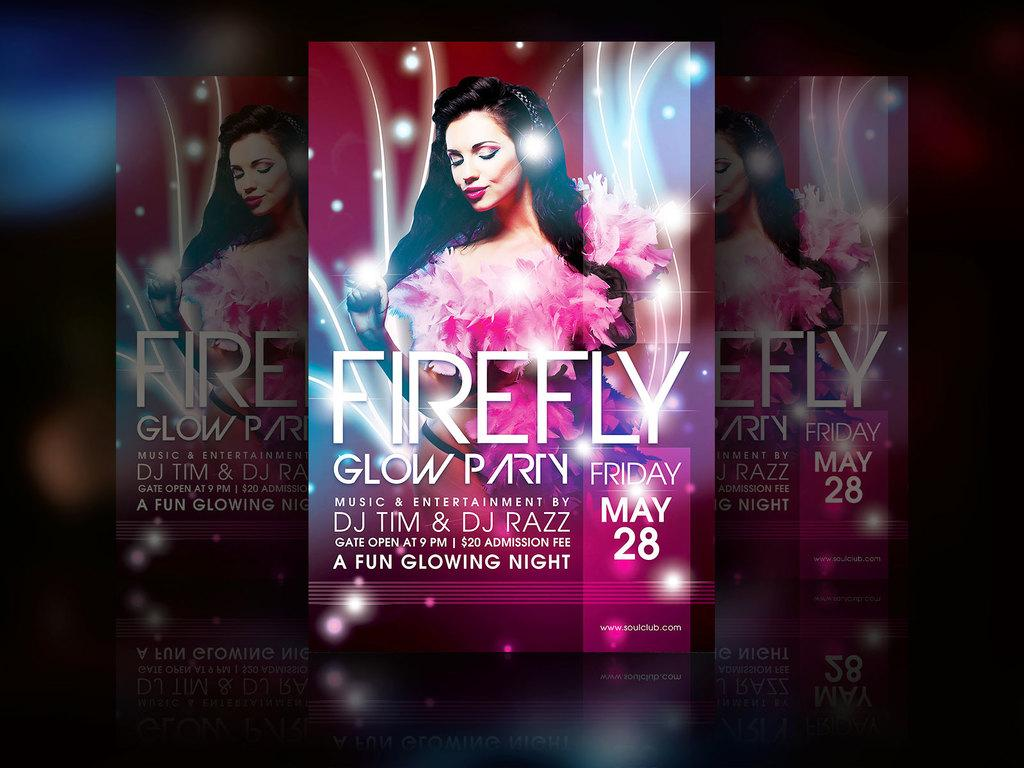<image>
Render a clear and concise summary of the photo. A flyer is promoting a glow party hosted by DJ Tim and DJ Razz. 